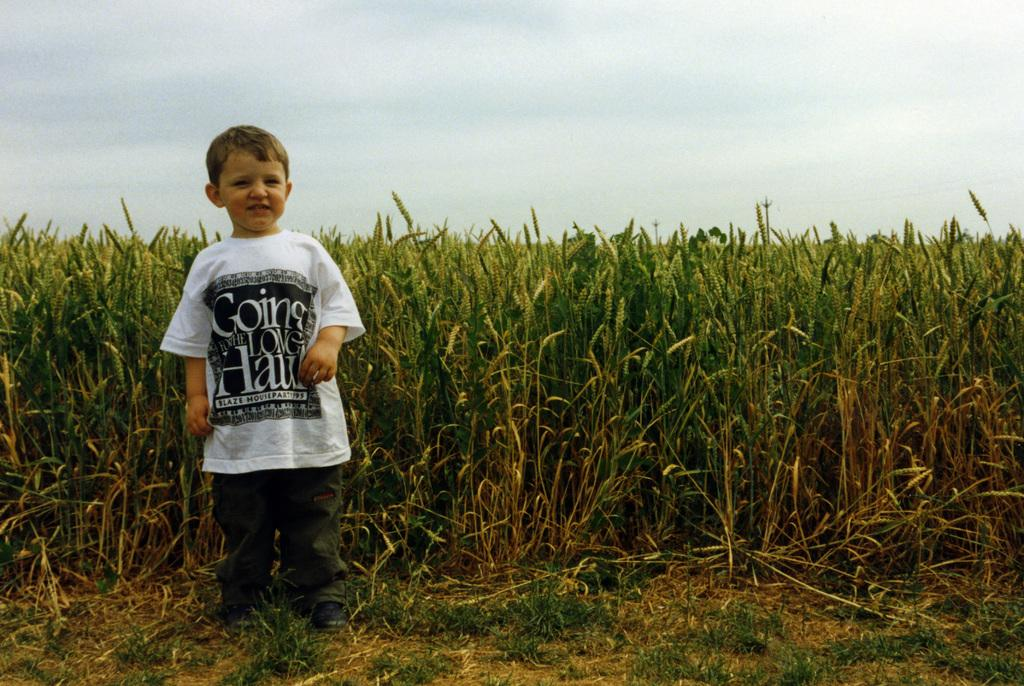Who is in the image? There is a boy in the image. What is the boy doing in the image? The boy is smiling in the image. Where is the boy standing in the image? The boy is standing on the ground in the image. What else can be seen in the image besides the boy? There are plants in the image. What can be seen in the background of the image? The sky is visible in the background of the image. Where is the nearest store to the boy in the image? There is no information about a store in the image, so it cannot be determined. 